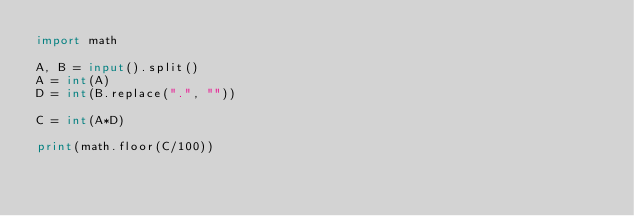Convert code to text. <code><loc_0><loc_0><loc_500><loc_500><_Python_>import math

A, B = input().split()
A = int(A)
D = int(B.replace(".", ""))

C = int(A*D)

print(math.floor(C/100))</code> 